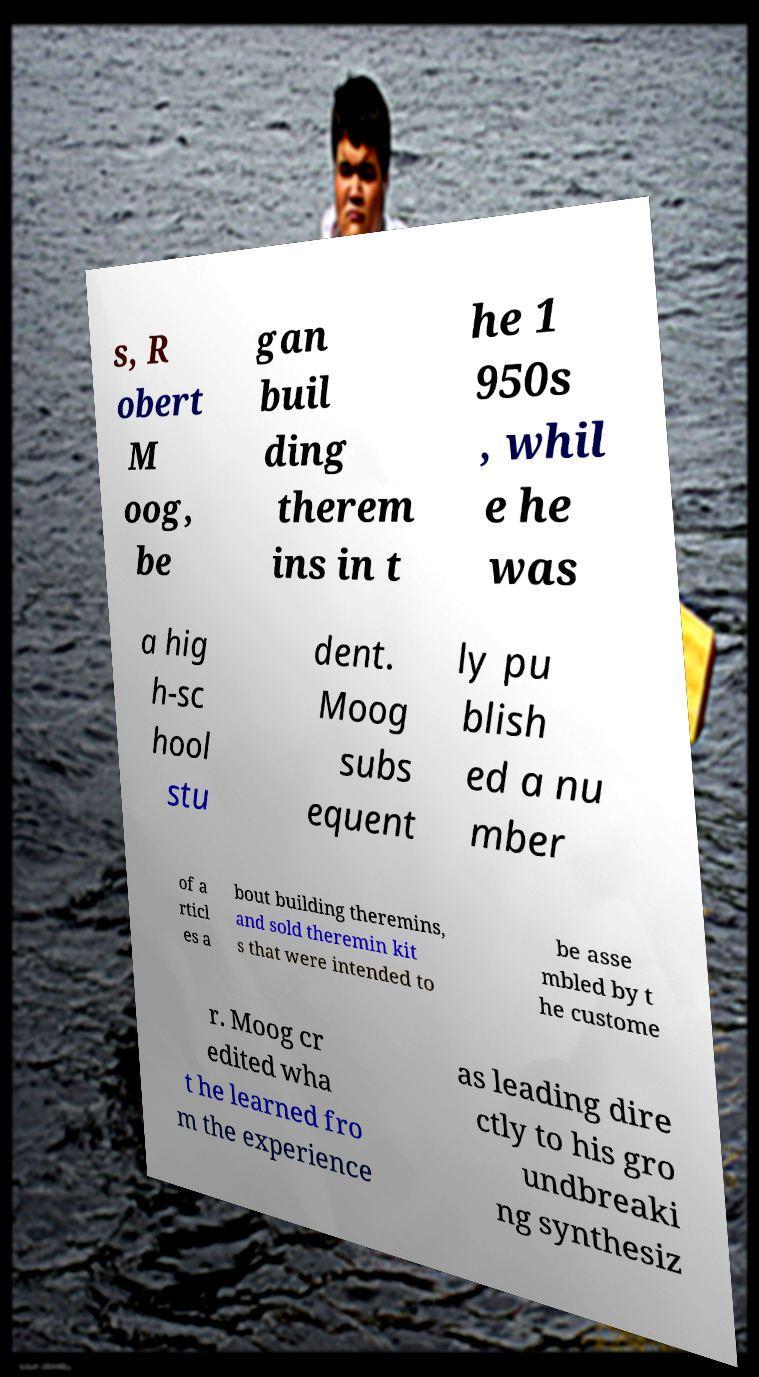Please identify and transcribe the text found in this image. s, R obert M oog, be gan buil ding therem ins in t he 1 950s , whil e he was a hig h-sc hool stu dent. Moog subs equent ly pu blish ed a nu mber of a rticl es a bout building theremins, and sold theremin kit s that were intended to be asse mbled by t he custome r. Moog cr edited wha t he learned fro m the experience as leading dire ctly to his gro undbreaki ng synthesiz 